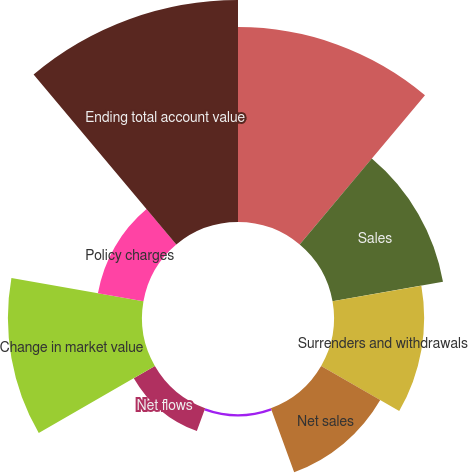<chart> <loc_0><loc_0><loc_500><loc_500><pie_chart><fcel>Beginning total account value<fcel>Sales<fcel>Surrenders and withdrawals<fcel>Net sales<fcel>Benefit payments<fcel>Net flows<fcel>Change in market value<fcel>Policy charges<fcel>Ending total account value<nl><fcel>21.79%<fcel>12.54%<fcel>10.08%<fcel>7.63%<fcel>0.26%<fcel>2.72%<fcel>14.99%<fcel>5.17%<fcel>24.82%<nl></chart> 